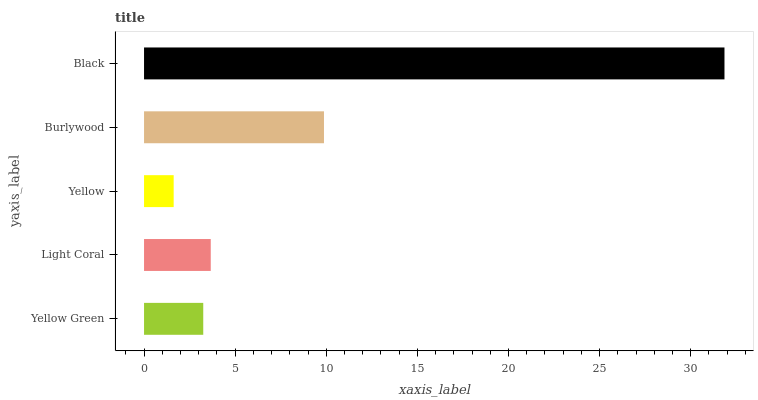Is Yellow the minimum?
Answer yes or no. Yes. Is Black the maximum?
Answer yes or no. Yes. Is Light Coral the minimum?
Answer yes or no. No. Is Light Coral the maximum?
Answer yes or no. No. Is Light Coral greater than Yellow Green?
Answer yes or no. Yes. Is Yellow Green less than Light Coral?
Answer yes or no. Yes. Is Yellow Green greater than Light Coral?
Answer yes or no. No. Is Light Coral less than Yellow Green?
Answer yes or no. No. Is Light Coral the high median?
Answer yes or no. Yes. Is Light Coral the low median?
Answer yes or no. Yes. Is Yellow Green the high median?
Answer yes or no. No. Is Yellow the low median?
Answer yes or no. No. 